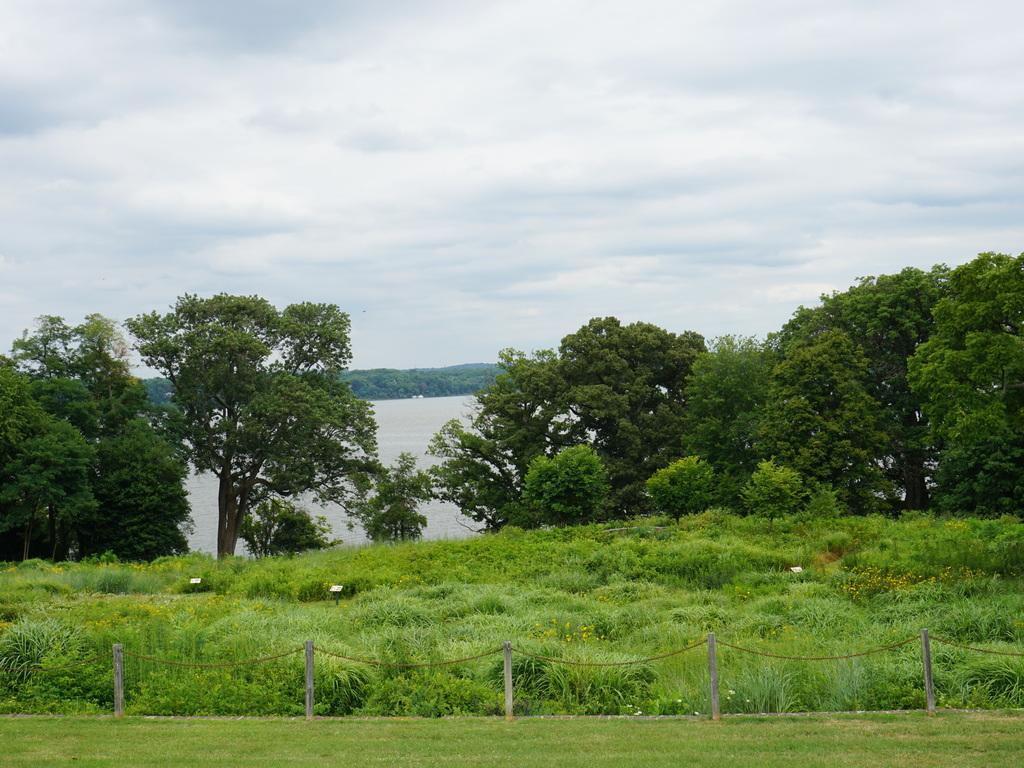In one or two sentences, can you explain what this image depicts? In front of the image there is a fence. There are plants, trees, lamps and water. At the bottom of the image there is grass on the surface. At the top of the image there are clouds in the sky. 